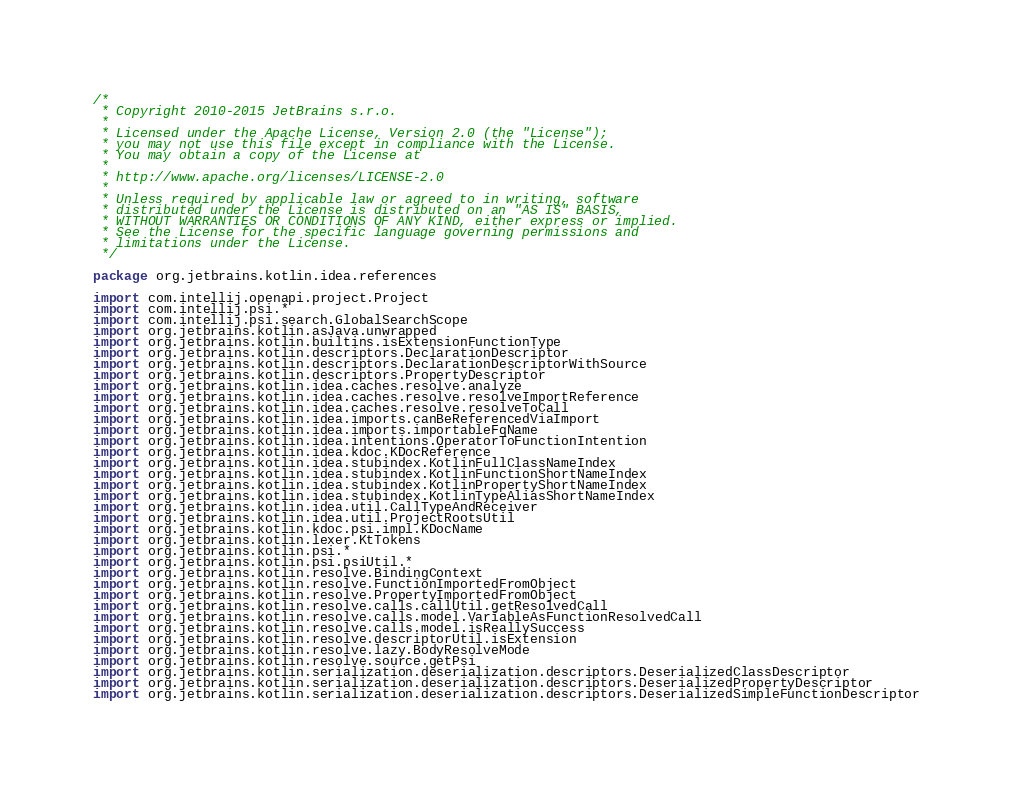<code> <loc_0><loc_0><loc_500><loc_500><_Kotlin_>/*
 * Copyright 2010-2015 JetBrains s.r.o.
 *
 * Licensed under the Apache License, Version 2.0 (the "License");
 * you may not use this file except in compliance with the License.
 * You may obtain a copy of the License at
 *
 * http://www.apache.org/licenses/LICENSE-2.0
 *
 * Unless required by applicable law or agreed to in writing, software
 * distributed under the License is distributed on an "AS IS" BASIS,
 * WITHOUT WARRANTIES OR CONDITIONS OF ANY KIND, either express or implied.
 * See the License for the specific language governing permissions and
 * limitations under the License.
 */

package org.jetbrains.kotlin.idea.references

import com.intellij.openapi.project.Project
import com.intellij.psi.*
import com.intellij.psi.search.GlobalSearchScope
import org.jetbrains.kotlin.asJava.unwrapped
import org.jetbrains.kotlin.builtins.isExtensionFunctionType
import org.jetbrains.kotlin.descriptors.DeclarationDescriptor
import org.jetbrains.kotlin.descriptors.DeclarationDescriptorWithSource
import org.jetbrains.kotlin.descriptors.PropertyDescriptor
import org.jetbrains.kotlin.idea.caches.resolve.analyze
import org.jetbrains.kotlin.idea.caches.resolve.resolveImportReference
import org.jetbrains.kotlin.idea.caches.resolve.resolveToCall
import org.jetbrains.kotlin.idea.imports.canBeReferencedViaImport
import org.jetbrains.kotlin.idea.imports.importableFqName
import org.jetbrains.kotlin.idea.intentions.OperatorToFunctionIntention
import org.jetbrains.kotlin.idea.kdoc.KDocReference
import org.jetbrains.kotlin.idea.stubindex.KotlinFullClassNameIndex
import org.jetbrains.kotlin.idea.stubindex.KotlinFunctionShortNameIndex
import org.jetbrains.kotlin.idea.stubindex.KotlinPropertyShortNameIndex
import org.jetbrains.kotlin.idea.stubindex.KotlinTypeAliasShortNameIndex
import org.jetbrains.kotlin.idea.util.CallTypeAndReceiver
import org.jetbrains.kotlin.idea.util.ProjectRootsUtil
import org.jetbrains.kotlin.kdoc.psi.impl.KDocName
import org.jetbrains.kotlin.lexer.KtTokens
import org.jetbrains.kotlin.psi.*
import org.jetbrains.kotlin.psi.psiUtil.*
import org.jetbrains.kotlin.resolve.BindingContext
import org.jetbrains.kotlin.resolve.FunctionImportedFromObject
import org.jetbrains.kotlin.resolve.PropertyImportedFromObject
import org.jetbrains.kotlin.resolve.calls.callUtil.getResolvedCall
import org.jetbrains.kotlin.resolve.calls.model.VariableAsFunctionResolvedCall
import org.jetbrains.kotlin.resolve.calls.model.isReallySuccess
import org.jetbrains.kotlin.resolve.descriptorUtil.isExtension
import org.jetbrains.kotlin.resolve.lazy.BodyResolveMode
import org.jetbrains.kotlin.resolve.source.getPsi
import org.jetbrains.kotlin.serialization.deserialization.descriptors.DeserializedClassDescriptor
import org.jetbrains.kotlin.serialization.deserialization.descriptors.DeserializedPropertyDescriptor
import org.jetbrains.kotlin.serialization.deserialization.descriptors.DeserializedSimpleFunctionDescriptor</code> 